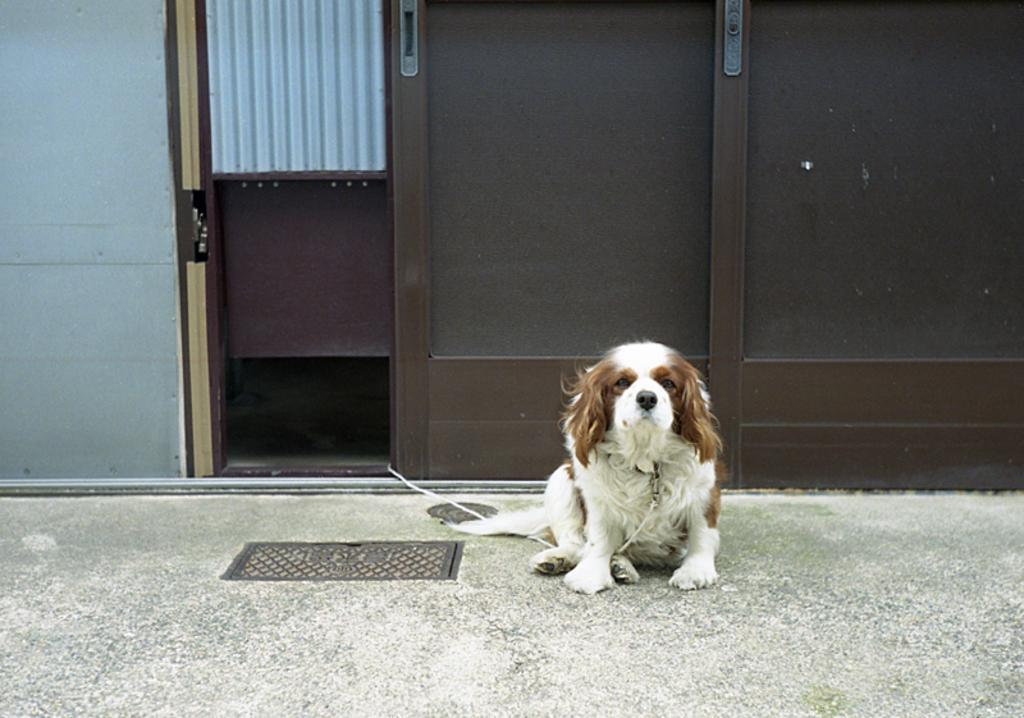What is the dog in the image holding in its mouth? The dog has a rope in its mouth in the image. What position is the dog in? The dog is sitting on the ground in the image. What can be seen in the background of the image? There is a wall with a door in the background of the image. What type of feature is present on the ground in the image? There is a manhole on the ground in the image. What type of mitten is the dog wearing on its paw in the image? There is no mitten present on the dog's paw in the image. What is the cause of the dog's sitting position in the image? The image does not provide information about the cause of the dog's sitting position. 